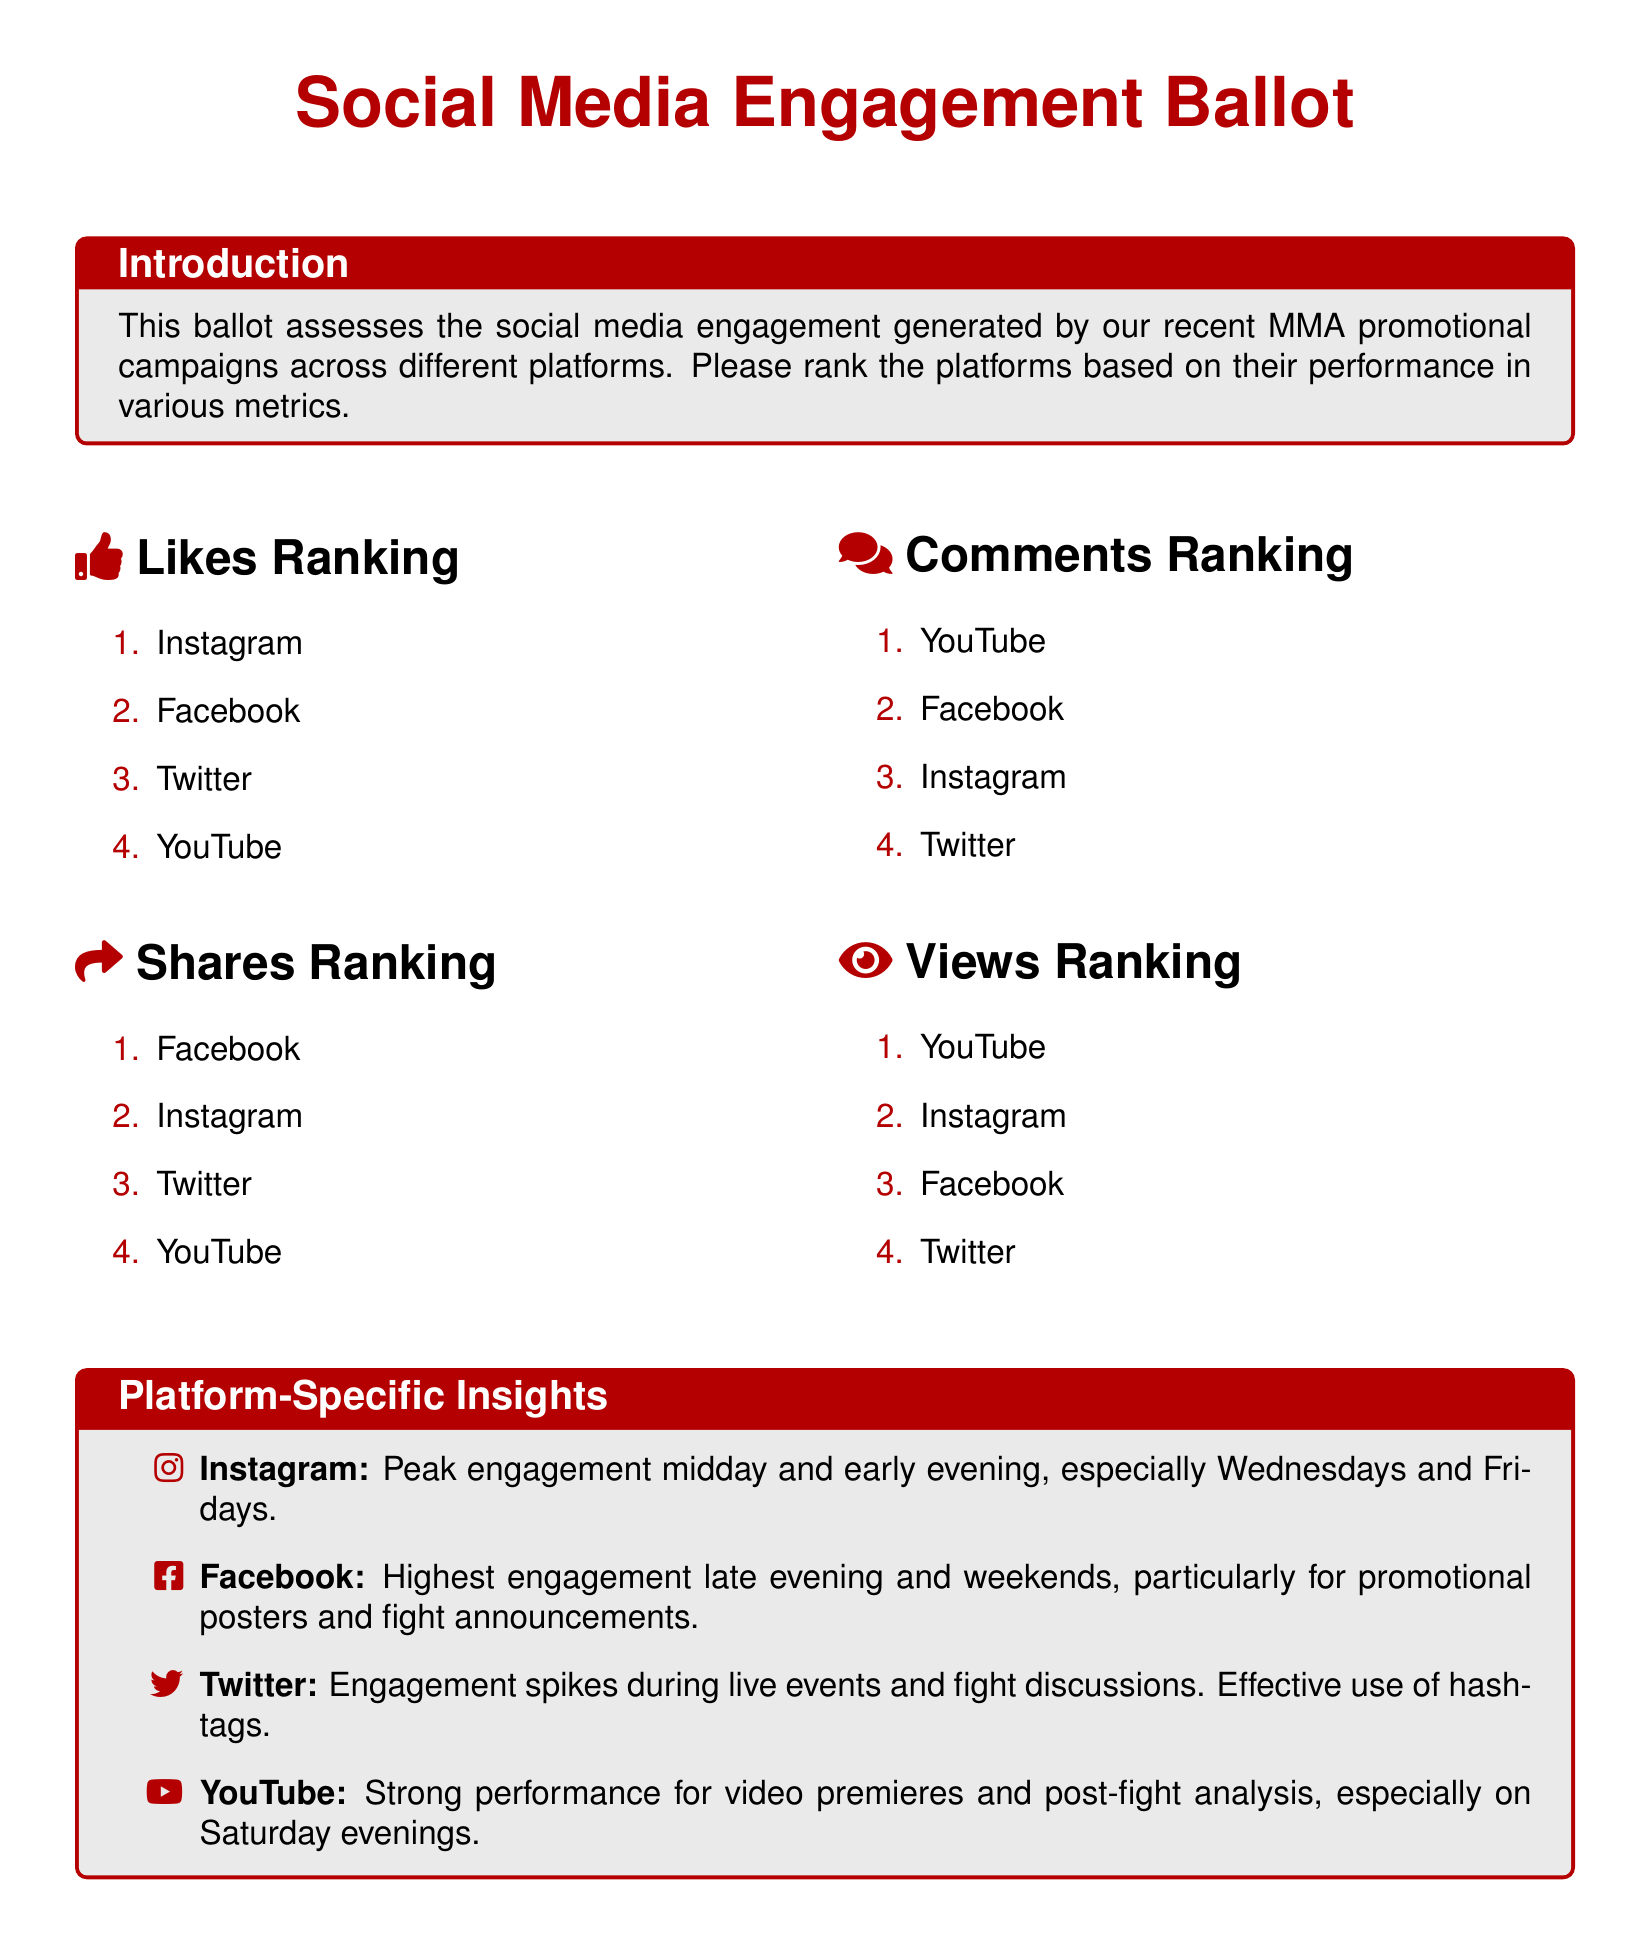what is the highest ranked platform for Likes? The highest ranked platform for Likes is found in the Likes Ranking section, which lists Instagram first.
Answer: Instagram which platform has the most Shares? The platform with the most Shares is specified in the Shares Ranking section, where Facebook is listed first.
Answer: Facebook which platform ranks the highest for Comments? The ranking for Comments indicates the platform that generates the most comments, with YouTube at the top.
Answer: YouTube what time of day does Instagram peak in engagement? The insights for Instagram mention that peak engagement occurs midday and early evening.
Answer: Midday and early evening what is the signature placeholder text? The document includes a placeholder for the voter's signature, which indicates where to sign.
Answer: Voter's Signature which platform is noted for strong performance during live events? The insights highlight Twitter's engagement spikes during live events, indicating its effectiveness during such times.
Answer: Twitter which platforms are mentioned for weekend engagement? The insights suggest that Facebook has the highest engagement late evening and weekends.
Answer: Facebook what day is mentioned for peak Instagram engagement? The insights indicate that Wednesdays and Fridays are specific days for peak engagement on Instagram.
Answer: Wednesdays and Fridays which platform is effective for promotional posters? Facebook is highlighted for high engagement on promotional posters, making it effective for that purpose.
Answer: Facebook 